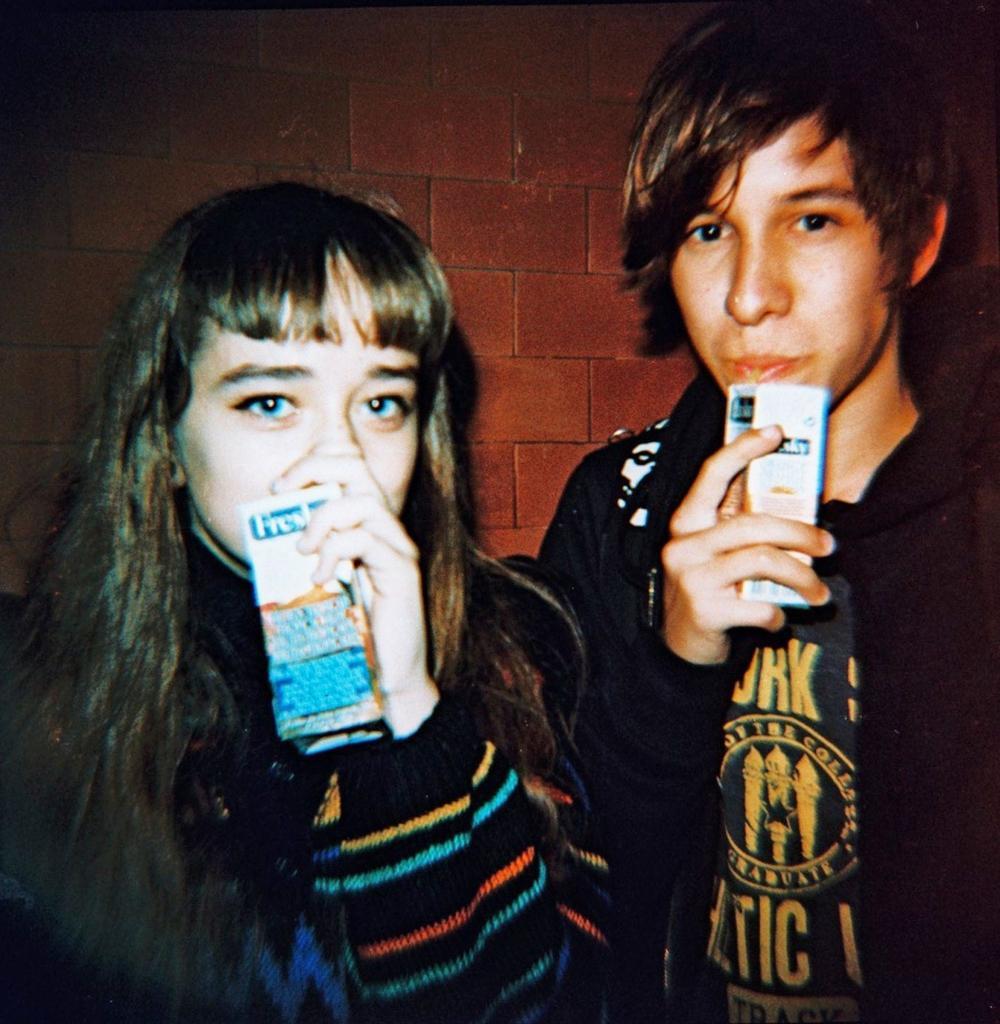Describe this image in one or two sentences. This is the picture. In picture there a man and a women the women is in a long hair, women wearing a sweater the man wearing a black t shirt and black jacket. Background of the two person is a wall with red bricks and the two persons were drinking a drink. 